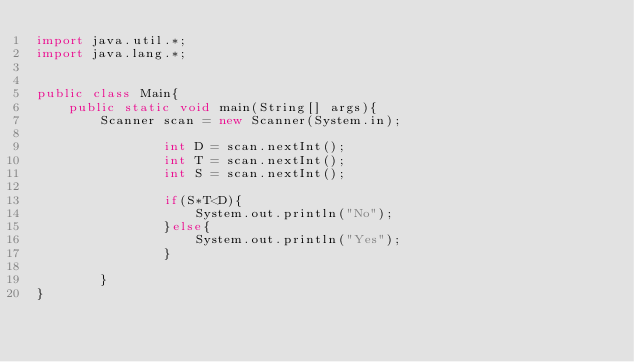<code> <loc_0><loc_0><loc_500><loc_500><_Java_>import java.util.*; 
import java.lang.*; 


public class Main{
	public static void main(String[] args){
		Scanner scan = new Scanner(System.in);
                
                int D = scan.nextInt();
                int T = scan.nextInt();
                int S = scan.nextInt();
                
                if(S*T<D){
                    System.out.println("No");
                }else{
                    System.out.println("Yes");
                }
                                         
        }
}</code> 